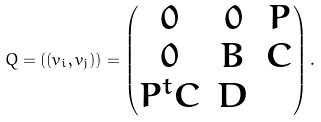Convert formula to latex. <formula><loc_0><loc_0><loc_500><loc_500>Q = ( ( v _ { i } , v _ { j } ) ) = \begin{pmatrix} 0 & 0 & P \\ 0 & B & C \\ P ^ { t } C & D \end{pmatrix} .</formula> 